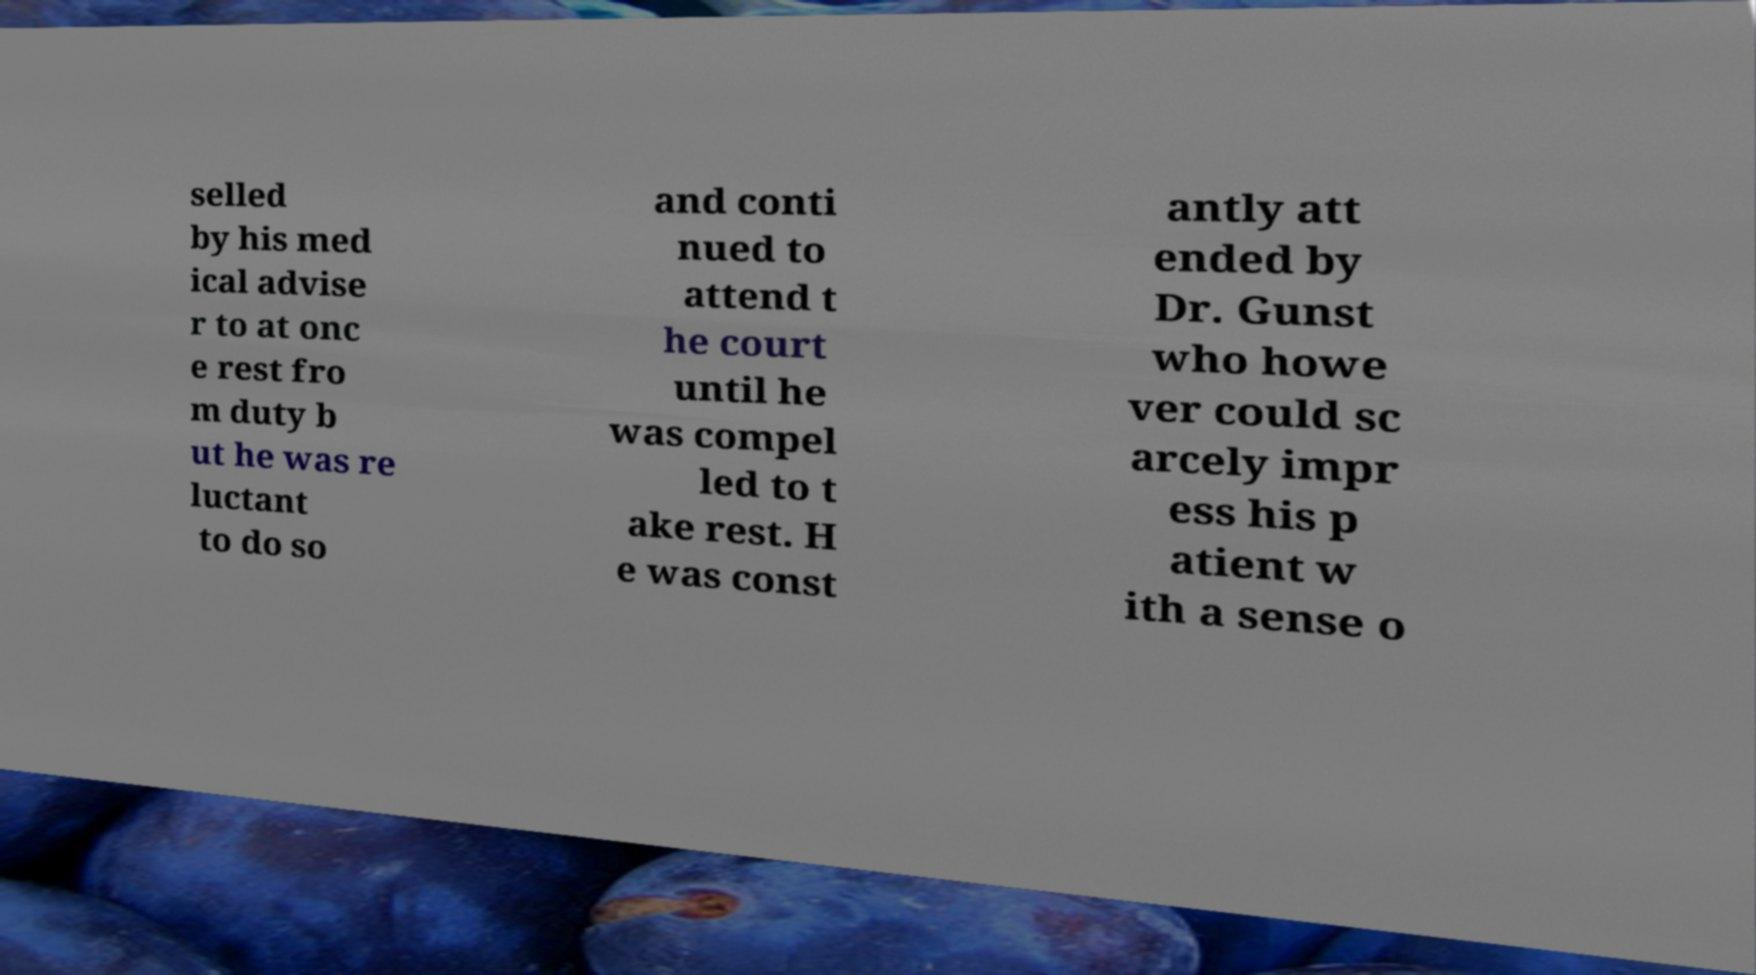Could you extract and type out the text from this image? selled by his med ical advise r to at onc e rest fro m duty b ut he was re luctant to do so and conti nued to attend t he court until he was compel led to t ake rest. H e was const antly att ended by Dr. Gunst who howe ver could sc arcely impr ess his p atient w ith a sense o 